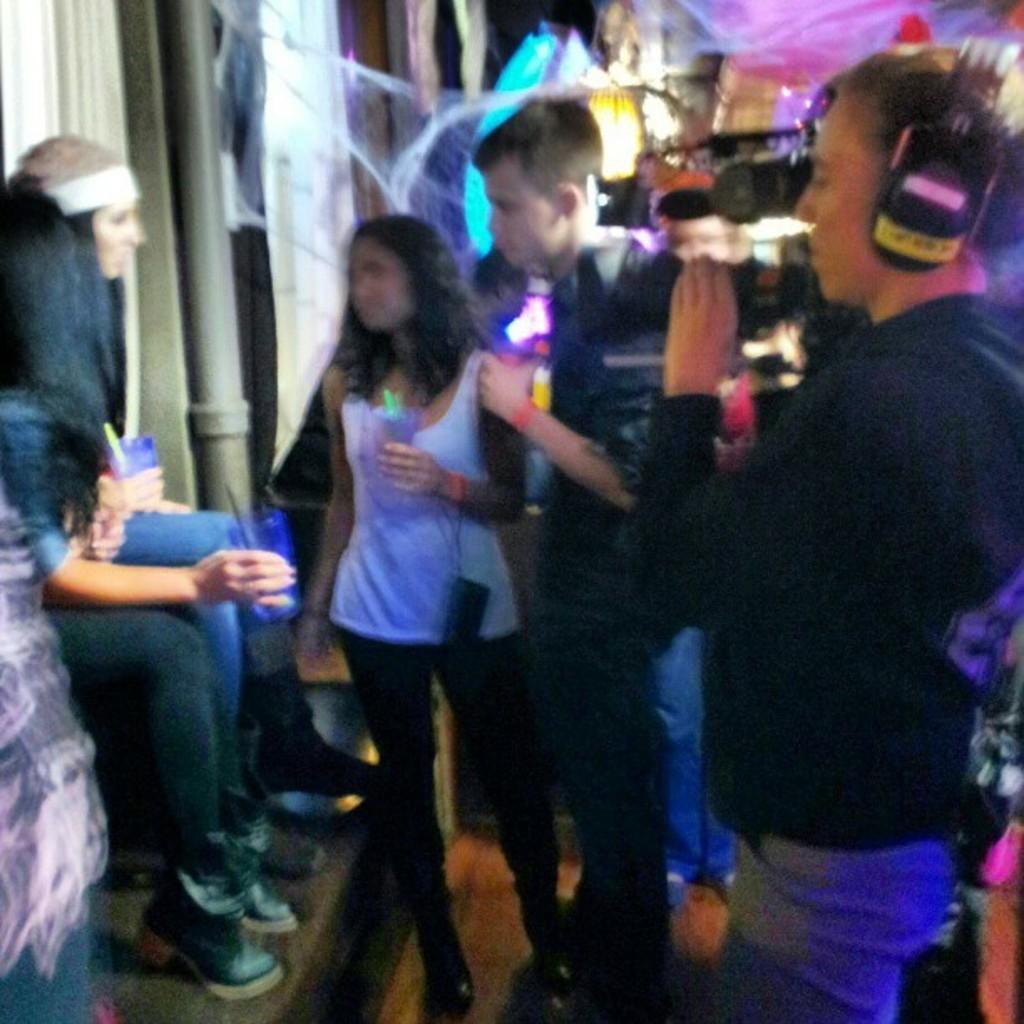In one or two sentences, can you explain what this image depicts? Right side a person is standing and shooting with the camera. On the left side 2 girls are sitting. 